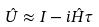Convert formula to latex. <formula><loc_0><loc_0><loc_500><loc_500>\hat { U } \approx I - i \hat { H } \tau</formula> 